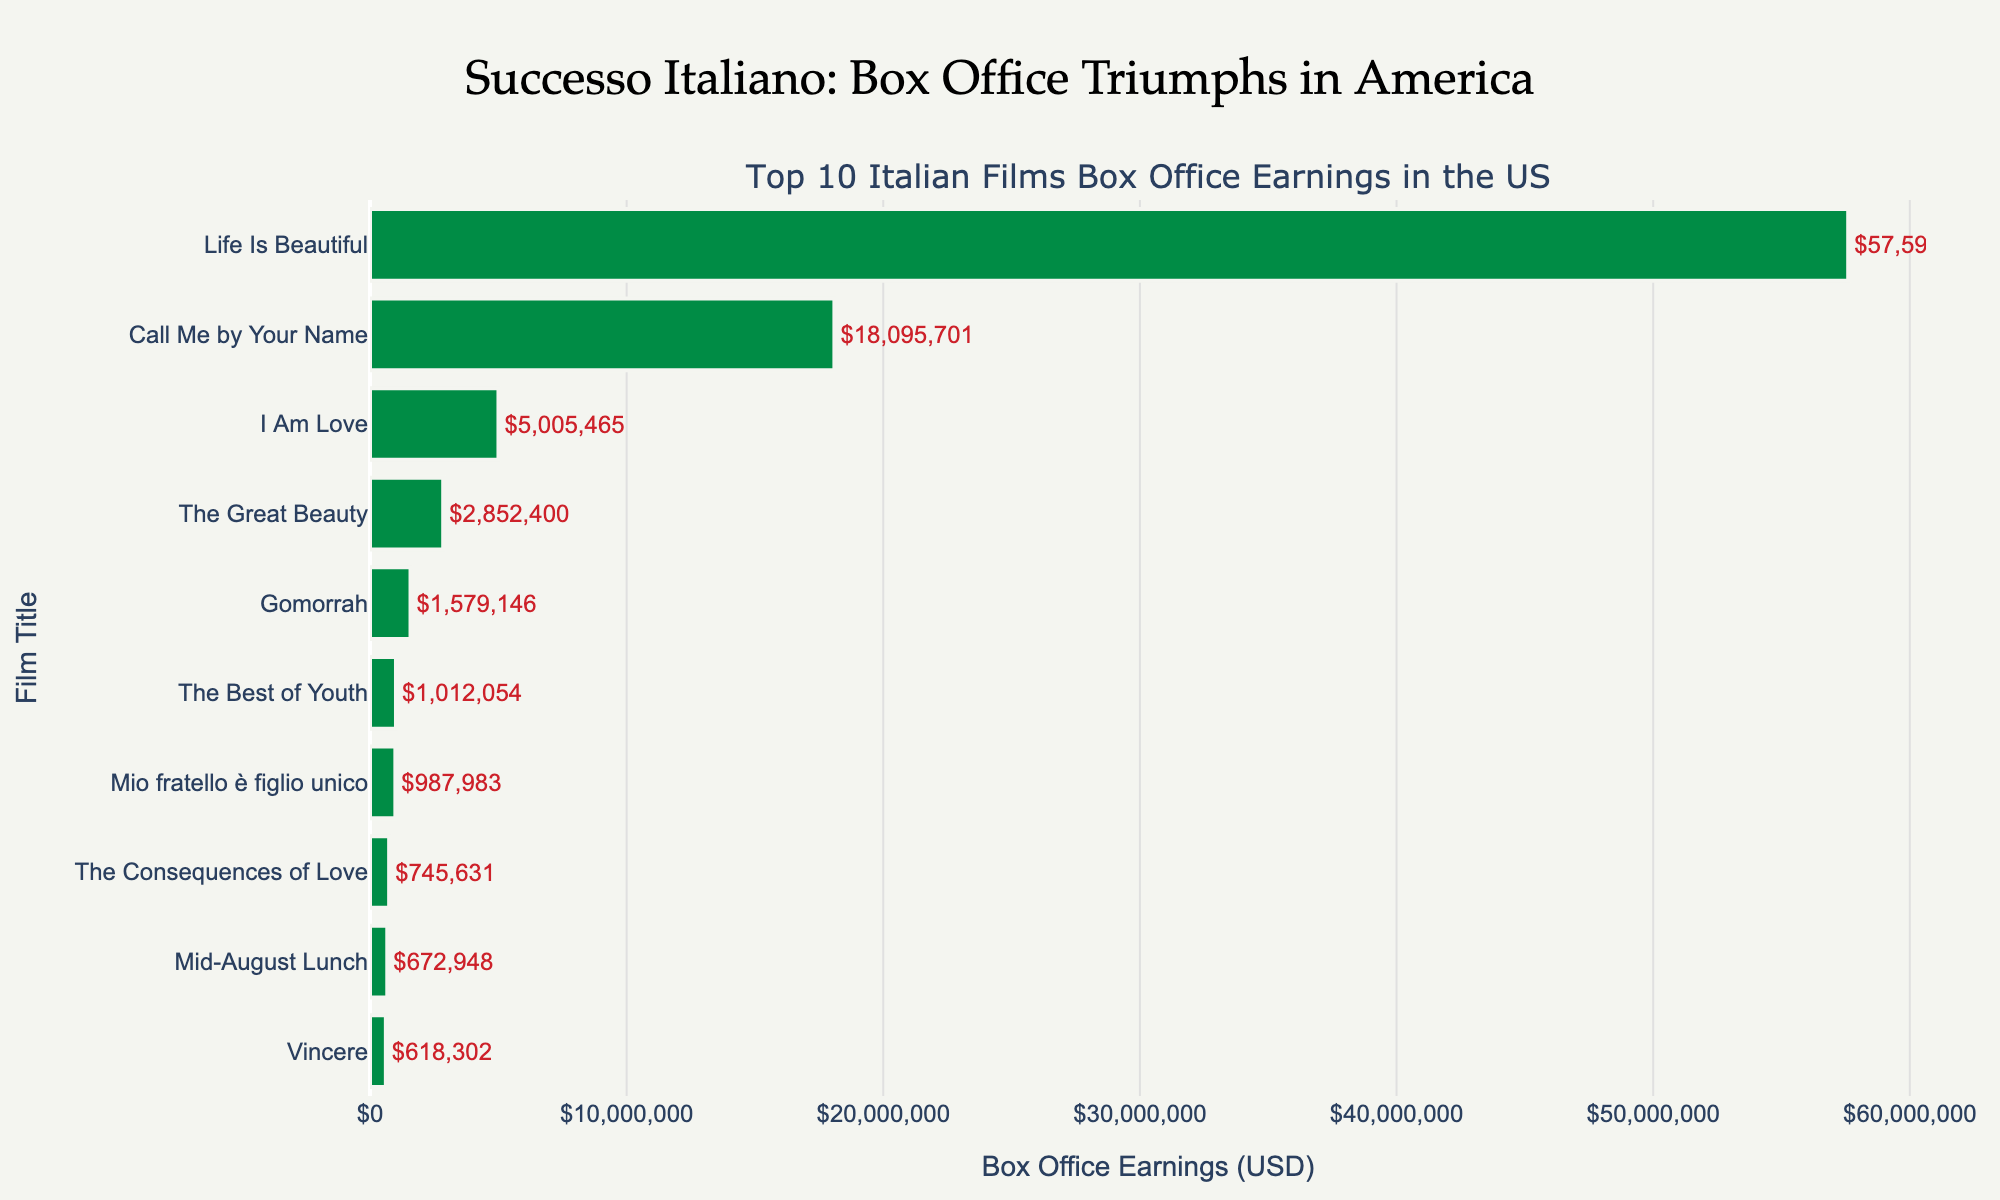How many movies earned more than $10 million? There are only two movies that have their earnings above $10 million: "Life Is Beautiful" and "Call Me by Your Name".
Answer: 2 Which film amassed the highest box office earnings? "Life Is Beautiful" has the tallest bar in the bar chart, indicating the highest earnings.
Answer: Life Is Beautiful What is the total box office earnings of "The Great Beauty" and "Gomorrah"? To find the total, add the earnings of both movies: $2,852,400 (The Great Beauty) + $1,579,146 (Gomorrah).
Answer: $4,431,546 Which movie earned the least at the US box office? "Vincere" has the shortest bar in the chart, indicating the least earnings.
Answer: Vincere By how much did "Life Is Beautiful" outperform "Call Me by Your Name"? Subtract the earnings of "Call Me by Your Name" from "Life Is Beautiful". $57,598,247 - $18,095,701 = $39,502,546.
Answer: $39,502,546 Which film occupies the middle rank in terms of box office earnings? The middle rank, or median, is the 5th one when sorted. "I Am Love" is in the middle of the sorted list.
Answer: I Am Love What combined percentage of the total earnings do "Life Is Beautiful" and "Call Me by Your Name" represent? Calculate the total earnings first and then the percentage. Total earnings of all films = $102,594,875. Combined earnings of the two films = $57,598,247 + $18,095,701 = $75,693,948. Percentage = ($75,693,948 / $102,594,875) * 100 = 73.8%.
Answer: 73.8% How much more did "The Best of Youth" earn compared to "The Consequences of Love"? Subtract the earnings of "The Consequences of Love" from "The Best of Youth". $1,012,054 - $745,631 = $266,423.
Answer: $266,423 Which films earned more than "Mio fratello è figlio unico" but less than "Call Me by Your Name"? Identify the films that fall within this range: "I Am Love".
Answer: I Am Love What is the average box office earnings of all the films in the chart? Sum all the box office earnings and divide by the number of films: Total is $102,594,875 and there are 10 films. Average = $102,594,875 / 10 = $10,259,487.50.
Answer: $10,259,488 